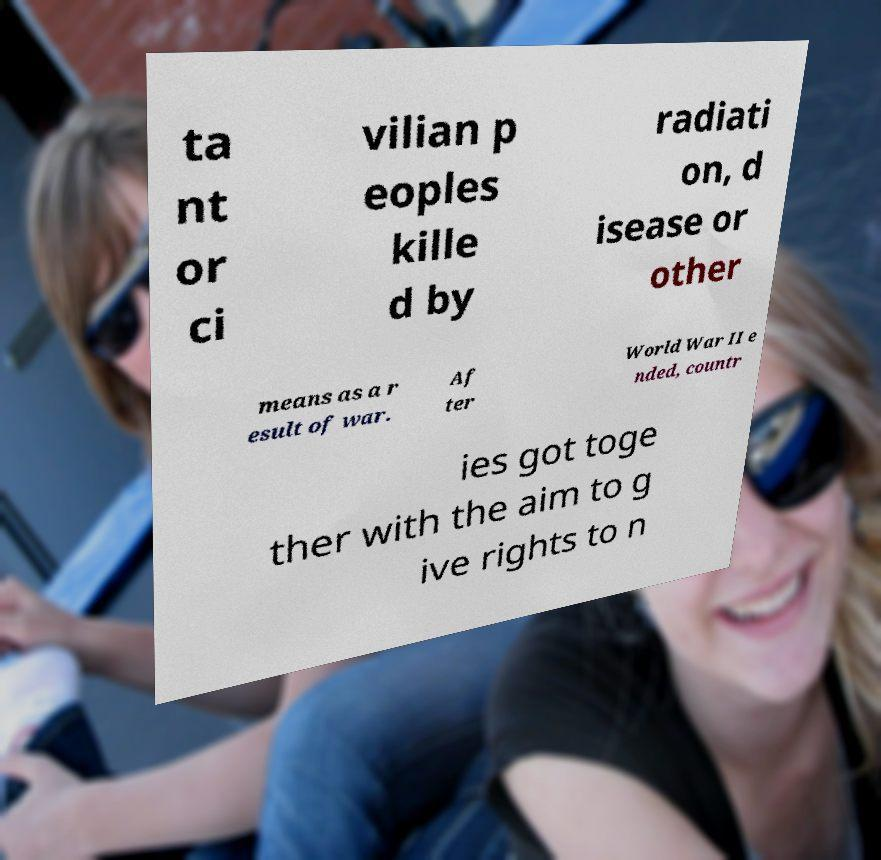What messages or text are displayed in this image? I need them in a readable, typed format. ta nt or ci vilian p eoples kille d by radiati on, d isease or other means as a r esult of war. Af ter World War II e nded, countr ies got toge ther with the aim to g ive rights to n 